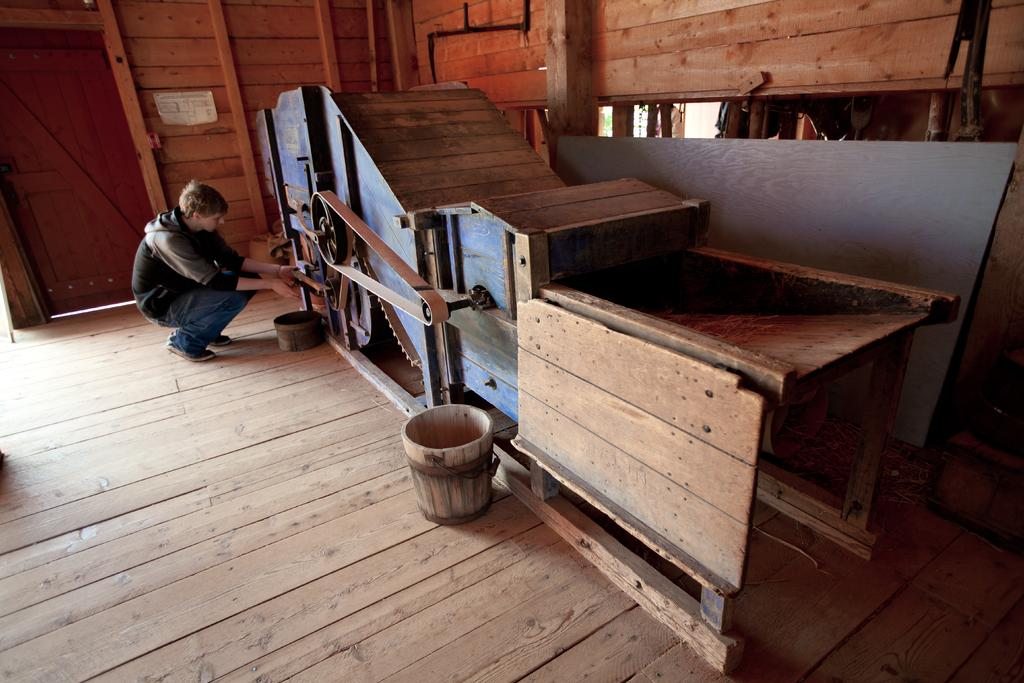What objects can be seen in the image? There are buckets, a wheel, and door pipes in the image. What is the person in the image doing? The person is on the floor in the image. What can be seen on the wall in the background of the image? There is a poster on the wall in the background of the image. Can you see any snails crawling on the buckets in the image? There are no snails visible in the image; it only shows buckets, a wheel, door pipes, a person on the floor, and a poster on the wall. 